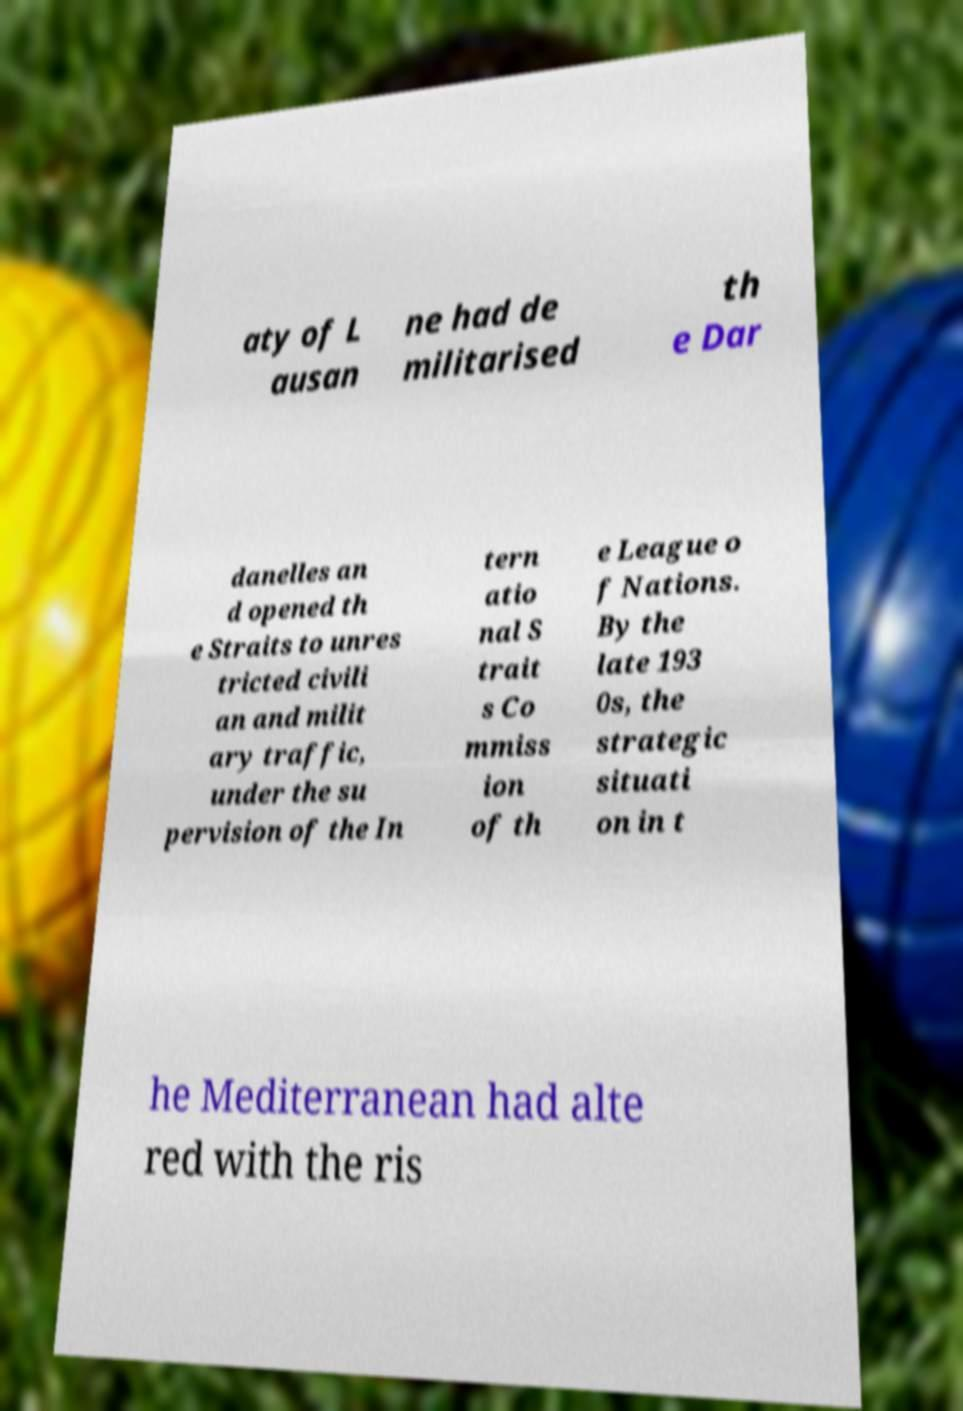I need the written content from this picture converted into text. Can you do that? aty of L ausan ne had de militarised th e Dar danelles an d opened th e Straits to unres tricted civili an and milit ary traffic, under the su pervision of the In tern atio nal S trait s Co mmiss ion of th e League o f Nations. By the late 193 0s, the strategic situati on in t he Mediterranean had alte red with the ris 